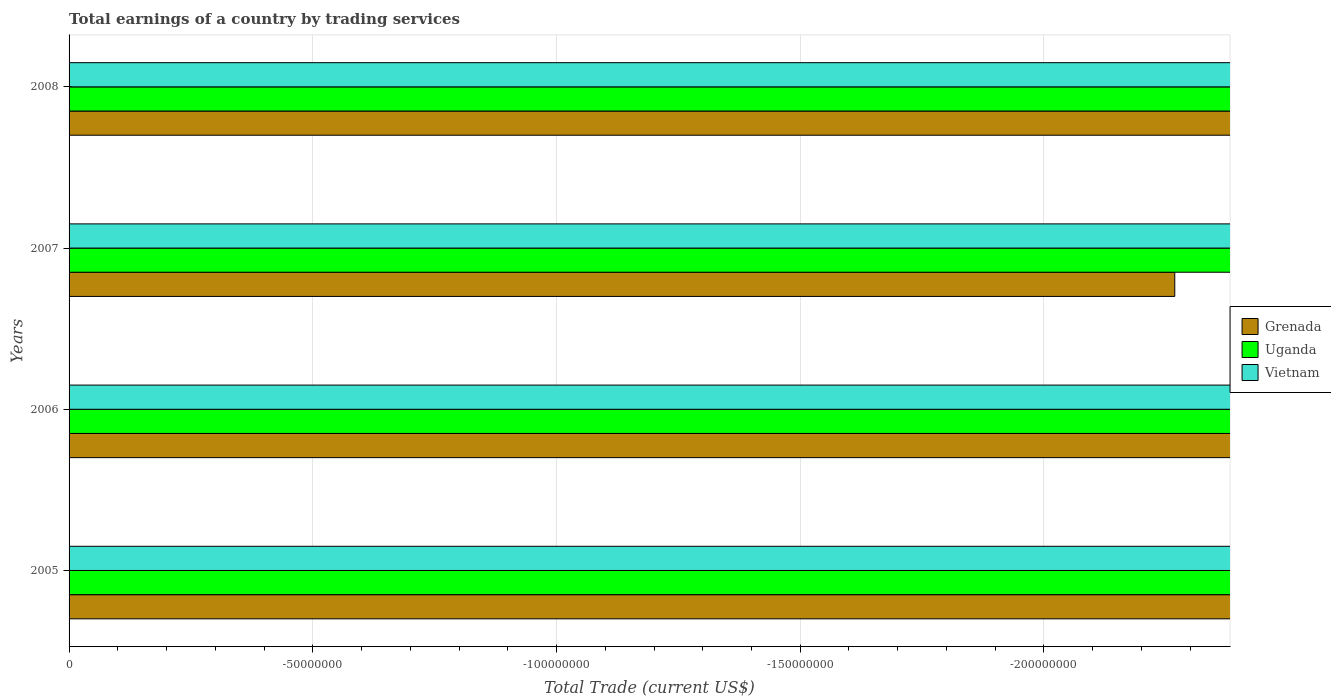How many bars are there on the 3rd tick from the top?
Offer a terse response. 0. In how many cases, is the number of bars for a given year not equal to the number of legend labels?
Provide a succinct answer. 4. What is the total earnings in Vietnam in 2005?
Provide a succinct answer. 0. Across all years, what is the minimum total earnings in Vietnam?
Give a very brief answer. 0. What is the total total earnings in Uganda in the graph?
Make the answer very short. 0. What is the difference between the total earnings in Grenada in 2008 and the total earnings in Uganda in 2007?
Keep it short and to the point. 0. What is the average total earnings in Grenada per year?
Provide a succinct answer. 0. In how many years, is the total earnings in Uganda greater than -120000000 US$?
Provide a succinct answer. 0. In how many years, is the total earnings in Uganda greater than the average total earnings in Uganda taken over all years?
Make the answer very short. 0. How many bars are there?
Make the answer very short. 0. Are all the bars in the graph horizontal?
Ensure brevity in your answer.  Yes. How many years are there in the graph?
Your response must be concise. 4. What is the difference between two consecutive major ticks on the X-axis?
Keep it short and to the point. 5.00e+07. Are the values on the major ticks of X-axis written in scientific E-notation?
Your answer should be very brief. No. Does the graph contain any zero values?
Give a very brief answer. Yes. Where does the legend appear in the graph?
Provide a succinct answer. Center right. How are the legend labels stacked?
Offer a very short reply. Vertical. What is the title of the graph?
Your answer should be very brief. Total earnings of a country by trading services. Does "Macedonia" appear as one of the legend labels in the graph?
Make the answer very short. No. What is the label or title of the X-axis?
Your answer should be compact. Total Trade (current US$). What is the Total Trade (current US$) of Uganda in 2006?
Your answer should be compact. 0. What is the Total Trade (current US$) of Grenada in 2008?
Offer a terse response. 0. What is the Total Trade (current US$) of Uganda in 2008?
Give a very brief answer. 0. What is the Total Trade (current US$) of Vietnam in 2008?
Make the answer very short. 0. What is the total Total Trade (current US$) of Grenada in the graph?
Provide a succinct answer. 0. What is the total Total Trade (current US$) of Uganda in the graph?
Your answer should be very brief. 0. What is the total Total Trade (current US$) in Vietnam in the graph?
Ensure brevity in your answer.  0. What is the average Total Trade (current US$) in Uganda per year?
Keep it short and to the point. 0. 